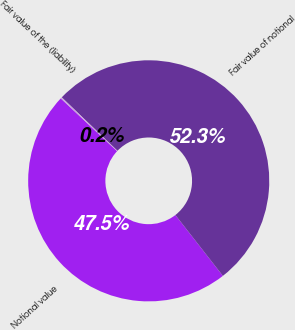<chart> <loc_0><loc_0><loc_500><loc_500><pie_chart><fcel>Notional value<fcel>Fair value of notional<fcel>Fair value of the (liability)<nl><fcel>47.53%<fcel>52.28%<fcel>0.19%<nl></chart> 